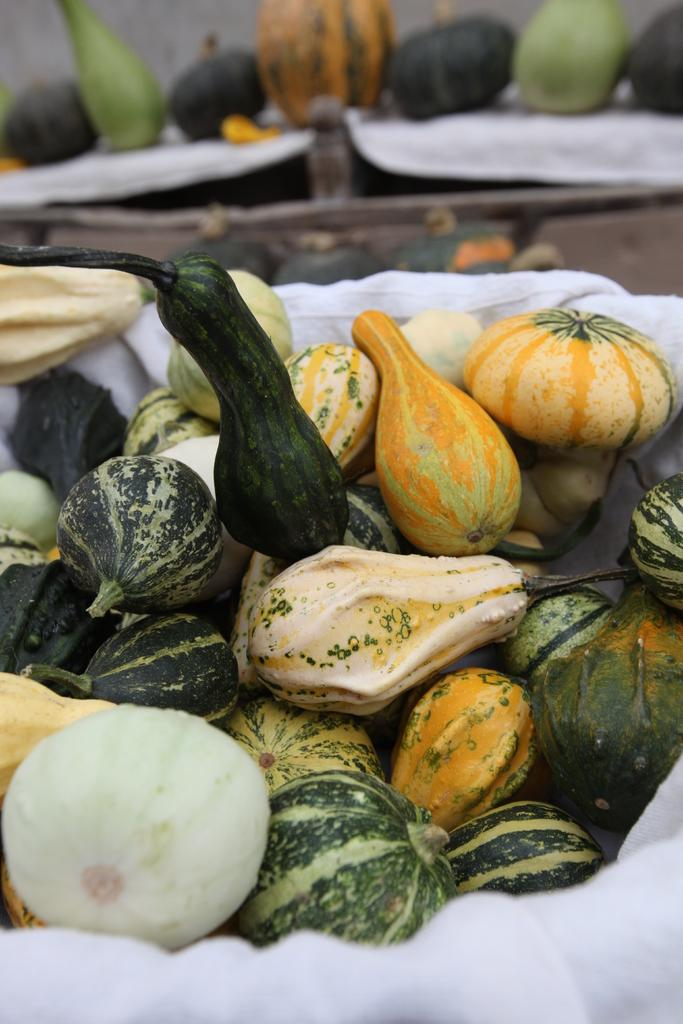What is the main subject in the center of the image? There is a basket of cucumbers in the center of the image. Are there any cucumbers visible outside of the basket? Yes, there are cucumbers at the top side of the image. What type of paste is being used to hold the bricks together in the image? There are no bricks or paste present in the image; it features a basket of cucumbers and additional cucumbers. 